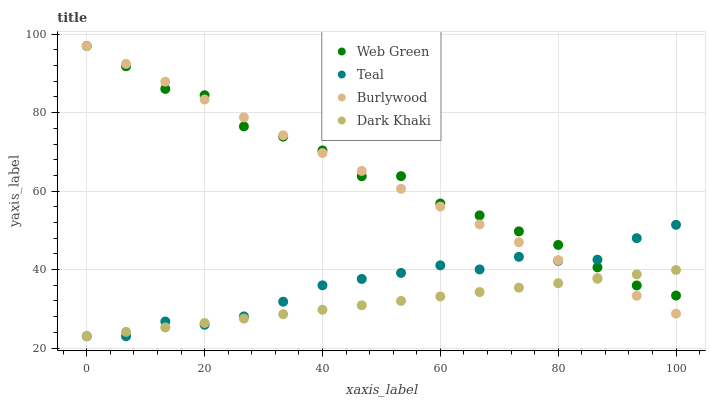Does Dark Khaki have the minimum area under the curve?
Answer yes or no. Yes. Does Web Green have the maximum area under the curve?
Answer yes or no. Yes. Does Teal have the minimum area under the curve?
Answer yes or no. No. Does Teal have the maximum area under the curve?
Answer yes or no. No. Is Dark Khaki the smoothest?
Answer yes or no. Yes. Is Web Green the roughest?
Answer yes or no. Yes. Is Teal the smoothest?
Answer yes or no. No. Is Teal the roughest?
Answer yes or no. No. Does Dark Khaki have the lowest value?
Answer yes or no. Yes. Does Web Green have the lowest value?
Answer yes or no. No. Does Web Green have the highest value?
Answer yes or no. Yes. Does Teal have the highest value?
Answer yes or no. No. Does Teal intersect Burlywood?
Answer yes or no. Yes. Is Teal less than Burlywood?
Answer yes or no. No. Is Teal greater than Burlywood?
Answer yes or no. No. 